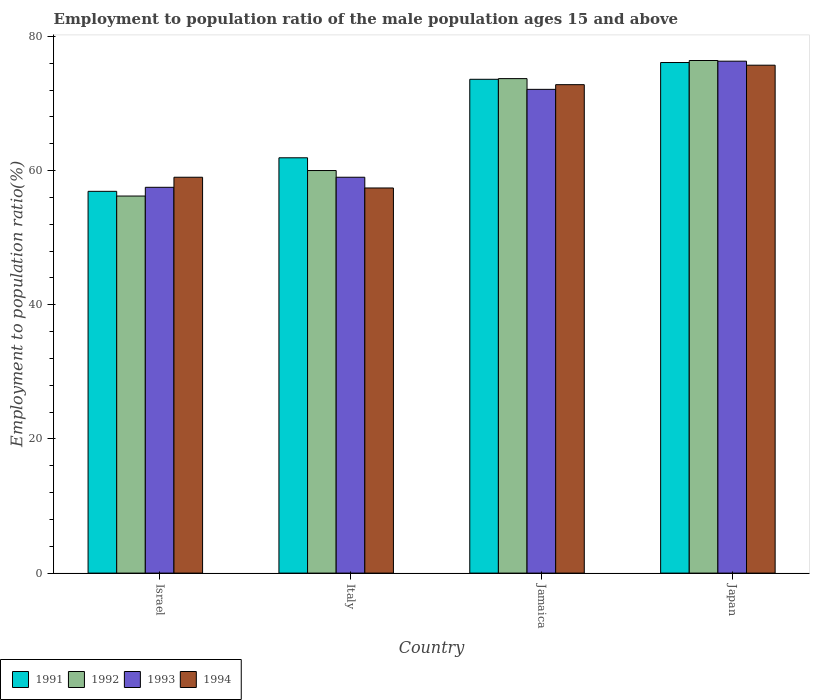How many bars are there on the 2nd tick from the left?
Make the answer very short. 4. How many bars are there on the 2nd tick from the right?
Your answer should be compact. 4. What is the employment to population ratio in 1992 in Italy?
Provide a succinct answer. 60. Across all countries, what is the maximum employment to population ratio in 1991?
Offer a very short reply. 76.1. Across all countries, what is the minimum employment to population ratio in 1992?
Offer a very short reply. 56.2. In which country was the employment to population ratio in 1994 minimum?
Make the answer very short. Italy. What is the total employment to population ratio in 1991 in the graph?
Your answer should be very brief. 268.5. What is the difference between the employment to population ratio in 1992 in Italy and that in Japan?
Your response must be concise. -16.4. What is the difference between the employment to population ratio in 1991 in Italy and the employment to population ratio in 1992 in Jamaica?
Your answer should be very brief. -11.8. What is the average employment to population ratio in 1992 per country?
Your answer should be compact. 66.57. What is the difference between the employment to population ratio of/in 1991 and employment to population ratio of/in 1994 in Israel?
Your answer should be compact. -2.1. In how many countries, is the employment to population ratio in 1992 greater than 56 %?
Your response must be concise. 4. What is the ratio of the employment to population ratio in 1994 in Israel to that in Japan?
Ensure brevity in your answer.  0.78. Is the difference between the employment to population ratio in 1991 in Italy and Jamaica greater than the difference between the employment to population ratio in 1994 in Italy and Jamaica?
Make the answer very short. Yes. What is the difference between the highest and the lowest employment to population ratio in 1992?
Your response must be concise. 20.2. In how many countries, is the employment to population ratio in 1994 greater than the average employment to population ratio in 1994 taken over all countries?
Offer a terse response. 2. Is it the case that in every country, the sum of the employment to population ratio in 1993 and employment to population ratio in 1992 is greater than the sum of employment to population ratio in 1994 and employment to population ratio in 1991?
Keep it short and to the point. No. What does the 2nd bar from the left in Jamaica represents?
Your response must be concise. 1992. Is it the case that in every country, the sum of the employment to population ratio in 1991 and employment to population ratio in 1992 is greater than the employment to population ratio in 1994?
Make the answer very short. Yes. How many bars are there?
Keep it short and to the point. 16. Are all the bars in the graph horizontal?
Provide a short and direct response. No. What is the difference between two consecutive major ticks on the Y-axis?
Make the answer very short. 20. Are the values on the major ticks of Y-axis written in scientific E-notation?
Offer a terse response. No. Does the graph contain grids?
Offer a very short reply. No. What is the title of the graph?
Ensure brevity in your answer.  Employment to population ratio of the male population ages 15 and above. Does "2014" appear as one of the legend labels in the graph?
Offer a terse response. No. What is the label or title of the Y-axis?
Your answer should be compact. Employment to population ratio(%). What is the Employment to population ratio(%) of 1991 in Israel?
Provide a short and direct response. 56.9. What is the Employment to population ratio(%) of 1992 in Israel?
Make the answer very short. 56.2. What is the Employment to population ratio(%) of 1993 in Israel?
Ensure brevity in your answer.  57.5. What is the Employment to population ratio(%) in 1994 in Israel?
Your answer should be compact. 59. What is the Employment to population ratio(%) of 1991 in Italy?
Provide a short and direct response. 61.9. What is the Employment to population ratio(%) in 1992 in Italy?
Ensure brevity in your answer.  60. What is the Employment to population ratio(%) of 1993 in Italy?
Make the answer very short. 59. What is the Employment to population ratio(%) in 1994 in Italy?
Keep it short and to the point. 57.4. What is the Employment to population ratio(%) in 1991 in Jamaica?
Your answer should be very brief. 73.6. What is the Employment to population ratio(%) of 1992 in Jamaica?
Keep it short and to the point. 73.7. What is the Employment to population ratio(%) of 1993 in Jamaica?
Your answer should be compact. 72.1. What is the Employment to population ratio(%) of 1994 in Jamaica?
Give a very brief answer. 72.8. What is the Employment to population ratio(%) of 1991 in Japan?
Give a very brief answer. 76.1. What is the Employment to population ratio(%) of 1992 in Japan?
Offer a terse response. 76.4. What is the Employment to population ratio(%) of 1993 in Japan?
Your response must be concise. 76.3. What is the Employment to population ratio(%) of 1994 in Japan?
Provide a succinct answer. 75.7. Across all countries, what is the maximum Employment to population ratio(%) of 1991?
Make the answer very short. 76.1. Across all countries, what is the maximum Employment to population ratio(%) of 1992?
Offer a terse response. 76.4. Across all countries, what is the maximum Employment to population ratio(%) of 1993?
Your answer should be very brief. 76.3. Across all countries, what is the maximum Employment to population ratio(%) of 1994?
Offer a terse response. 75.7. Across all countries, what is the minimum Employment to population ratio(%) of 1991?
Make the answer very short. 56.9. Across all countries, what is the minimum Employment to population ratio(%) in 1992?
Offer a terse response. 56.2. Across all countries, what is the minimum Employment to population ratio(%) of 1993?
Your response must be concise. 57.5. Across all countries, what is the minimum Employment to population ratio(%) of 1994?
Give a very brief answer. 57.4. What is the total Employment to population ratio(%) in 1991 in the graph?
Ensure brevity in your answer.  268.5. What is the total Employment to population ratio(%) of 1992 in the graph?
Provide a succinct answer. 266.3. What is the total Employment to population ratio(%) in 1993 in the graph?
Your answer should be very brief. 264.9. What is the total Employment to population ratio(%) of 1994 in the graph?
Keep it short and to the point. 264.9. What is the difference between the Employment to population ratio(%) of 1992 in Israel and that in Italy?
Ensure brevity in your answer.  -3.8. What is the difference between the Employment to population ratio(%) of 1994 in Israel and that in Italy?
Keep it short and to the point. 1.6. What is the difference between the Employment to population ratio(%) in 1991 in Israel and that in Jamaica?
Your response must be concise. -16.7. What is the difference between the Employment to population ratio(%) of 1992 in Israel and that in Jamaica?
Your answer should be very brief. -17.5. What is the difference between the Employment to population ratio(%) of 1993 in Israel and that in Jamaica?
Offer a terse response. -14.6. What is the difference between the Employment to population ratio(%) of 1994 in Israel and that in Jamaica?
Your response must be concise. -13.8. What is the difference between the Employment to population ratio(%) in 1991 in Israel and that in Japan?
Give a very brief answer. -19.2. What is the difference between the Employment to population ratio(%) in 1992 in Israel and that in Japan?
Provide a succinct answer. -20.2. What is the difference between the Employment to population ratio(%) of 1993 in Israel and that in Japan?
Make the answer very short. -18.8. What is the difference between the Employment to population ratio(%) in 1994 in Israel and that in Japan?
Give a very brief answer. -16.7. What is the difference between the Employment to population ratio(%) of 1991 in Italy and that in Jamaica?
Provide a succinct answer. -11.7. What is the difference between the Employment to population ratio(%) of 1992 in Italy and that in Jamaica?
Give a very brief answer. -13.7. What is the difference between the Employment to population ratio(%) in 1993 in Italy and that in Jamaica?
Give a very brief answer. -13.1. What is the difference between the Employment to population ratio(%) of 1994 in Italy and that in Jamaica?
Keep it short and to the point. -15.4. What is the difference between the Employment to population ratio(%) in 1991 in Italy and that in Japan?
Your response must be concise. -14.2. What is the difference between the Employment to population ratio(%) in 1992 in Italy and that in Japan?
Your response must be concise. -16.4. What is the difference between the Employment to population ratio(%) in 1993 in Italy and that in Japan?
Provide a short and direct response. -17.3. What is the difference between the Employment to population ratio(%) in 1994 in Italy and that in Japan?
Keep it short and to the point. -18.3. What is the difference between the Employment to population ratio(%) of 1993 in Jamaica and that in Japan?
Ensure brevity in your answer.  -4.2. What is the difference between the Employment to population ratio(%) in 1994 in Jamaica and that in Japan?
Your response must be concise. -2.9. What is the difference between the Employment to population ratio(%) of 1992 in Israel and the Employment to population ratio(%) of 1993 in Italy?
Provide a short and direct response. -2.8. What is the difference between the Employment to population ratio(%) in 1992 in Israel and the Employment to population ratio(%) in 1994 in Italy?
Provide a succinct answer. -1.2. What is the difference between the Employment to population ratio(%) in 1991 in Israel and the Employment to population ratio(%) in 1992 in Jamaica?
Give a very brief answer. -16.8. What is the difference between the Employment to population ratio(%) in 1991 in Israel and the Employment to population ratio(%) in 1993 in Jamaica?
Offer a very short reply. -15.2. What is the difference between the Employment to population ratio(%) in 1991 in Israel and the Employment to population ratio(%) in 1994 in Jamaica?
Provide a succinct answer. -15.9. What is the difference between the Employment to population ratio(%) in 1992 in Israel and the Employment to population ratio(%) in 1993 in Jamaica?
Offer a very short reply. -15.9. What is the difference between the Employment to population ratio(%) of 1992 in Israel and the Employment to population ratio(%) of 1994 in Jamaica?
Your answer should be compact. -16.6. What is the difference between the Employment to population ratio(%) of 1993 in Israel and the Employment to population ratio(%) of 1994 in Jamaica?
Provide a succinct answer. -15.3. What is the difference between the Employment to population ratio(%) in 1991 in Israel and the Employment to population ratio(%) in 1992 in Japan?
Provide a succinct answer. -19.5. What is the difference between the Employment to population ratio(%) in 1991 in Israel and the Employment to population ratio(%) in 1993 in Japan?
Offer a terse response. -19.4. What is the difference between the Employment to population ratio(%) of 1991 in Israel and the Employment to population ratio(%) of 1994 in Japan?
Your response must be concise. -18.8. What is the difference between the Employment to population ratio(%) in 1992 in Israel and the Employment to population ratio(%) in 1993 in Japan?
Provide a short and direct response. -20.1. What is the difference between the Employment to population ratio(%) in 1992 in Israel and the Employment to population ratio(%) in 1994 in Japan?
Keep it short and to the point. -19.5. What is the difference between the Employment to population ratio(%) in 1993 in Israel and the Employment to population ratio(%) in 1994 in Japan?
Provide a short and direct response. -18.2. What is the difference between the Employment to population ratio(%) of 1991 in Italy and the Employment to population ratio(%) of 1992 in Jamaica?
Your answer should be compact. -11.8. What is the difference between the Employment to population ratio(%) in 1991 in Italy and the Employment to population ratio(%) in 1994 in Jamaica?
Give a very brief answer. -10.9. What is the difference between the Employment to population ratio(%) in 1992 in Italy and the Employment to population ratio(%) in 1993 in Jamaica?
Keep it short and to the point. -12.1. What is the difference between the Employment to population ratio(%) in 1993 in Italy and the Employment to population ratio(%) in 1994 in Jamaica?
Provide a succinct answer. -13.8. What is the difference between the Employment to population ratio(%) of 1991 in Italy and the Employment to population ratio(%) of 1993 in Japan?
Offer a terse response. -14.4. What is the difference between the Employment to population ratio(%) of 1992 in Italy and the Employment to population ratio(%) of 1993 in Japan?
Keep it short and to the point. -16.3. What is the difference between the Employment to population ratio(%) in 1992 in Italy and the Employment to population ratio(%) in 1994 in Japan?
Offer a terse response. -15.7. What is the difference between the Employment to population ratio(%) in 1993 in Italy and the Employment to population ratio(%) in 1994 in Japan?
Your response must be concise. -16.7. What is the difference between the Employment to population ratio(%) of 1991 in Jamaica and the Employment to population ratio(%) of 1992 in Japan?
Your response must be concise. -2.8. What is the difference between the Employment to population ratio(%) in 1991 in Jamaica and the Employment to population ratio(%) in 1994 in Japan?
Provide a short and direct response. -2.1. What is the difference between the Employment to population ratio(%) in 1992 in Jamaica and the Employment to population ratio(%) in 1993 in Japan?
Keep it short and to the point. -2.6. What is the average Employment to population ratio(%) in 1991 per country?
Keep it short and to the point. 67.12. What is the average Employment to population ratio(%) in 1992 per country?
Keep it short and to the point. 66.58. What is the average Employment to population ratio(%) of 1993 per country?
Give a very brief answer. 66.22. What is the average Employment to population ratio(%) of 1994 per country?
Give a very brief answer. 66.22. What is the difference between the Employment to population ratio(%) of 1993 and Employment to population ratio(%) of 1994 in Israel?
Keep it short and to the point. -1.5. What is the difference between the Employment to population ratio(%) in 1991 and Employment to population ratio(%) in 1993 in Italy?
Provide a short and direct response. 2.9. What is the difference between the Employment to population ratio(%) of 1991 and Employment to population ratio(%) of 1994 in Italy?
Offer a very short reply. 4.5. What is the difference between the Employment to population ratio(%) in 1992 and Employment to population ratio(%) in 1993 in Italy?
Ensure brevity in your answer.  1. What is the difference between the Employment to population ratio(%) of 1992 and Employment to population ratio(%) of 1994 in Italy?
Provide a succinct answer. 2.6. What is the difference between the Employment to population ratio(%) in 1991 and Employment to population ratio(%) in 1993 in Jamaica?
Ensure brevity in your answer.  1.5. What is the difference between the Employment to population ratio(%) in 1993 and Employment to population ratio(%) in 1994 in Jamaica?
Give a very brief answer. -0.7. What is the difference between the Employment to population ratio(%) of 1991 and Employment to population ratio(%) of 1992 in Japan?
Provide a short and direct response. -0.3. What is the difference between the Employment to population ratio(%) of 1992 and Employment to population ratio(%) of 1993 in Japan?
Offer a terse response. 0.1. What is the difference between the Employment to population ratio(%) in 1993 and Employment to population ratio(%) in 1994 in Japan?
Offer a very short reply. 0.6. What is the ratio of the Employment to population ratio(%) in 1991 in Israel to that in Italy?
Your answer should be compact. 0.92. What is the ratio of the Employment to population ratio(%) of 1992 in Israel to that in Italy?
Offer a very short reply. 0.94. What is the ratio of the Employment to population ratio(%) in 1993 in Israel to that in Italy?
Give a very brief answer. 0.97. What is the ratio of the Employment to population ratio(%) of 1994 in Israel to that in Italy?
Offer a terse response. 1.03. What is the ratio of the Employment to population ratio(%) of 1991 in Israel to that in Jamaica?
Your response must be concise. 0.77. What is the ratio of the Employment to population ratio(%) in 1992 in Israel to that in Jamaica?
Provide a succinct answer. 0.76. What is the ratio of the Employment to population ratio(%) in 1993 in Israel to that in Jamaica?
Make the answer very short. 0.8. What is the ratio of the Employment to population ratio(%) in 1994 in Israel to that in Jamaica?
Offer a very short reply. 0.81. What is the ratio of the Employment to population ratio(%) of 1991 in Israel to that in Japan?
Give a very brief answer. 0.75. What is the ratio of the Employment to population ratio(%) of 1992 in Israel to that in Japan?
Provide a succinct answer. 0.74. What is the ratio of the Employment to population ratio(%) of 1993 in Israel to that in Japan?
Your answer should be very brief. 0.75. What is the ratio of the Employment to population ratio(%) of 1994 in Israel to that in Japan?
Give a very brief answer. 0.78. What is the ratio of the Employment to population ratio(%) of 1991 in Italy to that in Jamaica?
Keep it short and to the point. 0.84. What is the ratio of the Employment to population ratio(%) of 1992 in Italy to that in Jamaica?
Make the answer very short. 0.81. What is the ratio of the Employment to population ratio(%) of 1993 in Italy to that in Jamaica?
Your answer should be very brief. 0.82. What is the ratio of the Employment to population ratio(%) of 1994 in Italy to that in Jamaica?
Give a very brief answer. 0.79. What is the ratio of the Employment to population ratio(%) of 1991 in Italy to that in Japan?
Your response must be concise. 0.81. What is the ratio of the Employment to population ratio(%) of 1992 in Italy to that in Japan?
Offer a terse response. 0.79. What is the ratio of the Employment to population ratio(%) of 1993 in Italy to that in Japan?
Give a very brief answer. 0.77. What is the ratio of the Employment to population ratio(%) of 1994 in Italy to that in Japan?
Make the answer very short. 0.76. What is the ratio of the Employment to population ratio(%) of 1991 in Jamaica to that in Japan?
Offer a very short reply. 0.97. What is the ratio of the Employment to population ratio(%) of 1992 in Jamaica to that in Japan?
Provide a short and direct response. 0.96. What is the ratio of the Employment to population ratio(%) in 1993 in Jamaica to that in Japan?
Provide a succinct answer. 0.94. What is the ratio of the Employment to population ratio(%) of 1994 in Jamaica to that in Japan?
Your answer should be very brief. 0.96. What is the difference between the highest and the second highest Employment to population ratio(%) of 1992?
Give a very brief answer. 2.7. What is the difference between the highest and the second highest Employment to population ratio(%) in 1993?
Keep it short and to the point. 4.2. What is the difference between the highest and the second highest Employment to population ratio(%) of 1994?
Provide a short and direct response. 2.9. What is the difference between the highest and the lowest Employment to population ratio(%) of 1991?
Provide a succinct answer. 19.2. What is the difference between the highest and the lowest Employment to population ratio(%) in 1992?
Keep it short and to the point. 20.2. What is the difference between the highest and the lowest Employment to population ratio(%) of 1993?
Your response must be concise. 18.8. 